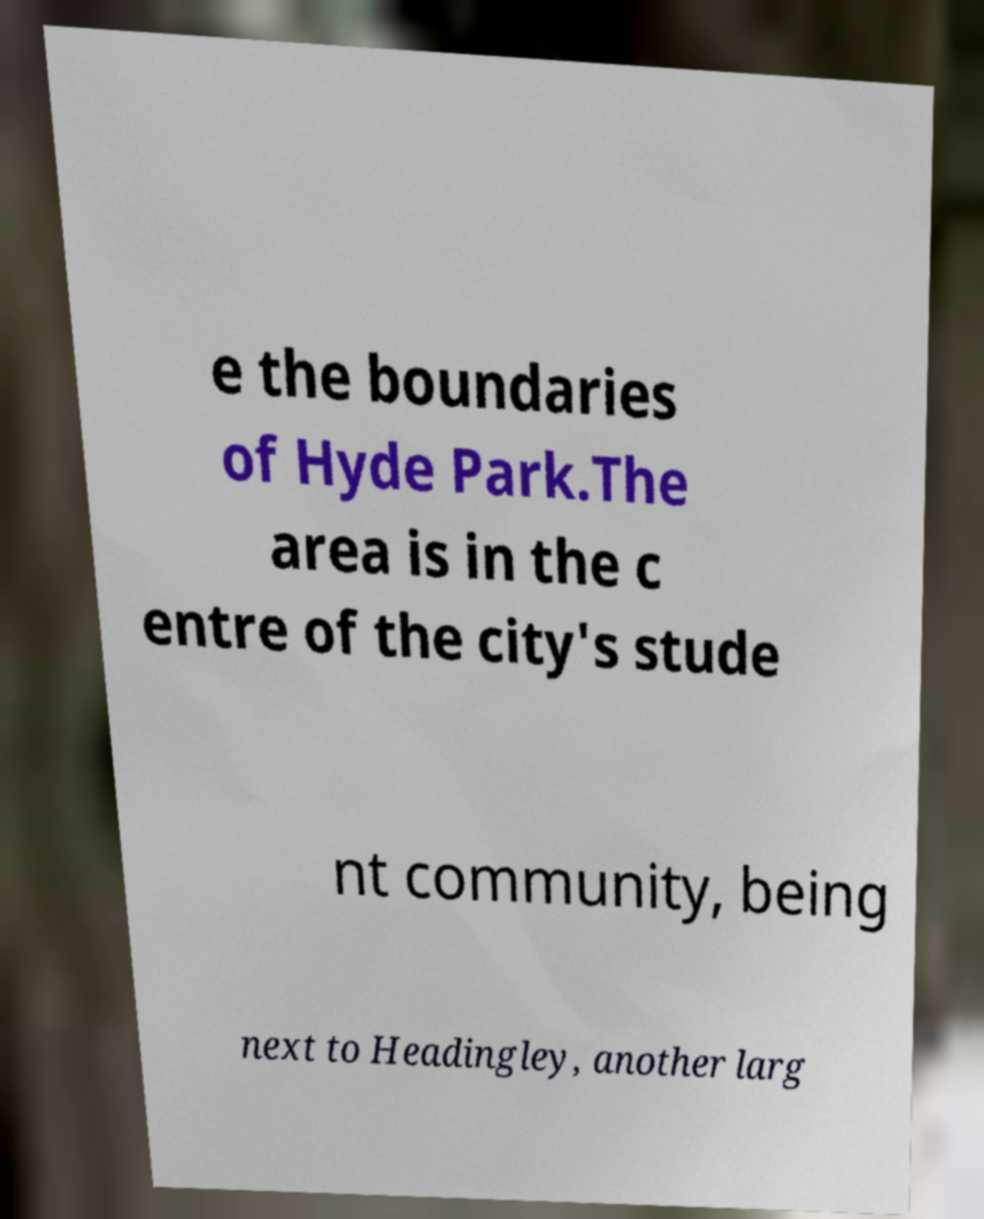For documentation purposes, I need the text within this image transcribed. Could you provide that? e the boundaries of Hyde Park.The area is in the c entre of the city's stude nt community, being next to Headingley, another larg 